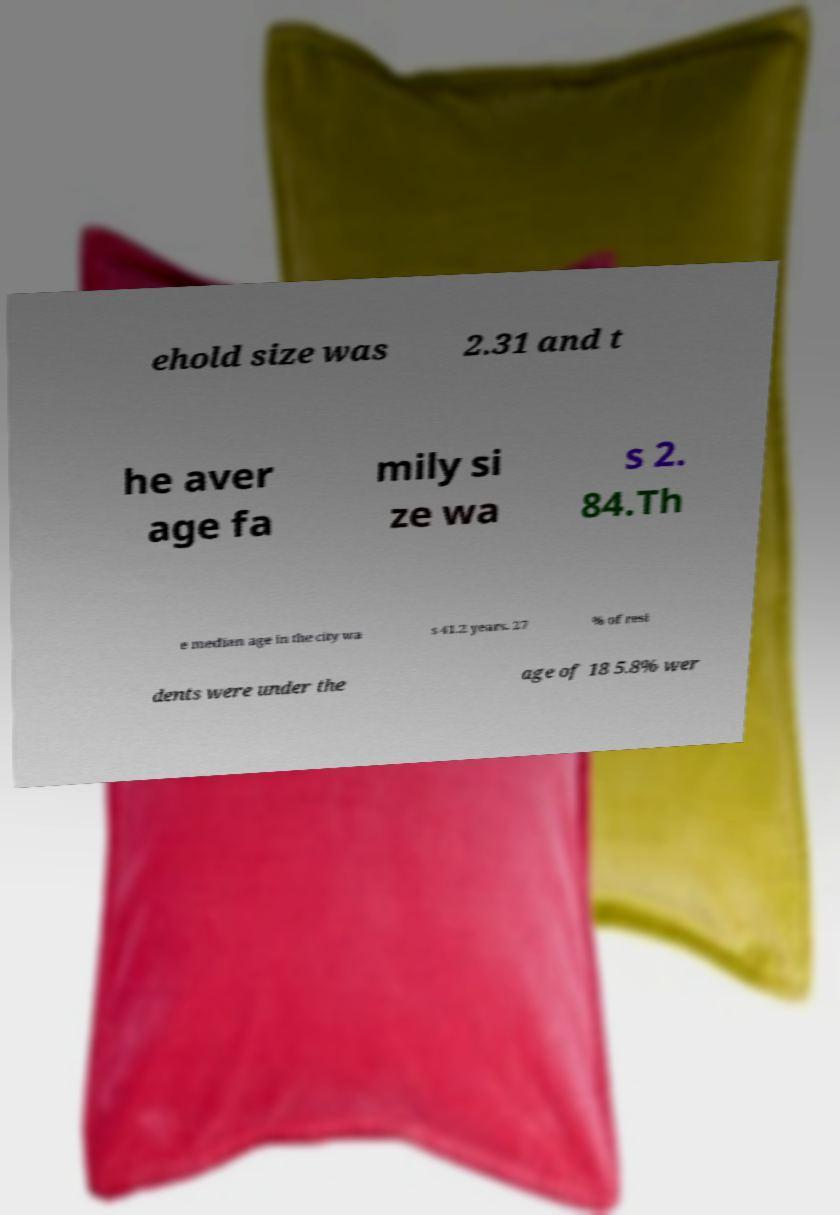Please identify and transcribe the text found in this image. ehold size was 2.31 and t he aver age fa mily si ze wa s 2. 84.Th e median age in the city wa s 41.2 years. 27 % of resi dents were under the age of 18 5.8% wer 